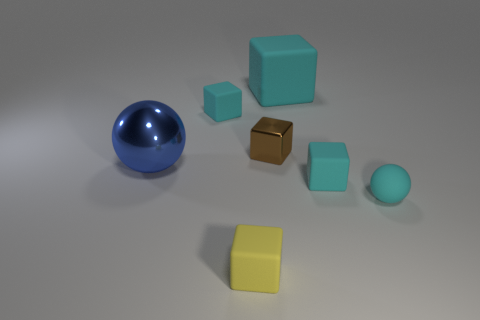What number of other things are there of the same color as the large rubber block?
Give a very brief answer. 3. Is the color of the big cube the same as the small sphere?
Your answer should be compact. Yes. Are there more matte blocks than shiny objects?
Ensure brevity in your answer.  Yes. What number of other things are there of the same material as the big block
Provide a succinct answer. 4. How many things are either big metallic objects or tiny matte cubes left of the small yellow rubber thing?
Provide a succinct answer. 2. Is the number of yellow matte cubes less than the number of small cyan matte objects?
Your answer should be compact. Yes. There is a matte object in front of the ball that is right of the cyan rubber block in front of the small brown thing; what is its color?
Provide a succinct answer. Yellow. Is the small yellow cube made of the same material as the big ball?
Provide a succinct answer. No. There is a big rubber block; how many small cyan things are to the right of it?
Your answer should be compact. 2. There is a yellow object that is the same shape as the small brown metal thing; what size is it?
Keep it short and to the point. Small. 